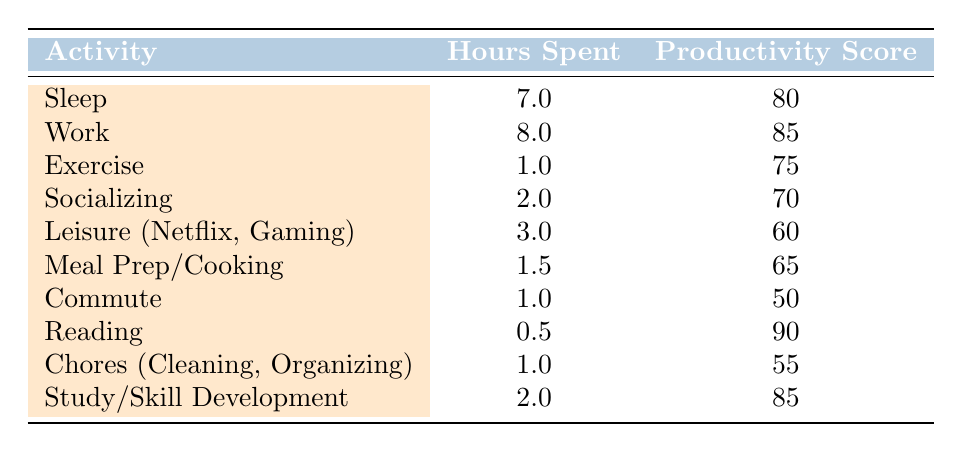What is the productivity score for Sleep? The table lists the productivity score for Sleep as 80.
Answer: 80 How many hours are spent on Leisure activities? Leisure (Netflix, Gaming) is stated to take 3 hours in the table.
Answer: 3 hours What is the average productivity score of all activities? To find the average productivity score, sum the scores: (80 + 85 + 75 + 70 + 60 + 65 + 50 + 90 + 55 + 85) = 855. There are 10 activities, so the average score is 855 / 10 = 85.5.
Answer: 85.5 Is the productivity score for Reading higher than for Exercise? The table shows Reading has a score of 90 and Exercise has 75, indicating that Reading's score is indeed higher.
Answer: Yes What is the total time spent on activities that have a productivity score of 70 or above? The qualifying scores are for Sleep (7 hours), Work (8 hours), Exercise (1 hour), Study/Skill Development (2 hours), and Reading (0.5 hours). Adding these gives: 7 + 8 + 1 + 2 + 0.5 = 18.5 hours.
Answer: 18.5 hours What is the productivity score for the activity with the least hours spent? The activity with the least hours spent is Reading with 0.5 hours and a productivity score of 90.
Answer: 90 Do more hours spent on Socializing correlate with a higher productivity score compared to the hours spent on Chores? Socializing is 2 hours with a score of 70, while Chores are 1 hour with a score of 55. Since 2 hours of Socializing leads to a higher score, the correlation here is positive in this instance.
Answer: Yes What is the difference in productivity scores between the highest and lowest scoring activities? The highest score is for Reading (90) and the lowest is for Commute (50). The difference is 90 - 50 = 40.
Answer: 40 Which activity takes the most time and what is its productivity score? The activity that takes the most time is Work with 8 hours, which has a productivity score of 85 as per the table.
Answer: 8 hours, 85 score 